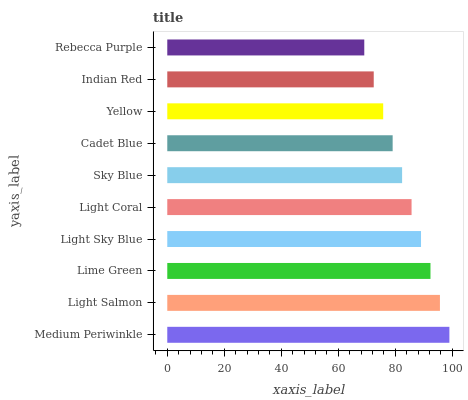Is Rebecca Purple the minimum?
Answer yes or no. Yes. Is Medium Periwinkle the maximum?
Answer yes or no. Yes. Is Light Salmon the minimum?
Answer yes or no. No. Is Light Salmon the maximum?
Answer yes or no. No. Is Medium Periwinkle greater than Light Salmon?
Answer yes or no. Yes. Is Light Salmon less than Medium Periwinkle?
Answer yes or no. Yes. Is Light Salmon greater than Medium Periwinkle?
Answer yes or no. No. Is Medium Periwinkle less than Light Salmon?
Answer yes or no. No. Is Light Coral the high median?
Answer yes or no. Yes. Is Sky Blue the low median?
Answer yes or no. Yes. Is Light Sky Blue the high median?
Answer yes or no. No. Is Cadet Blue the low median?
Answer yes or no. No. 